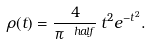<formula> <loc_0><loc_0><loc_500><loc_500>\rho ( t ) = \frac { 4 } { \pi ^ { \ h a l f } } \, t ^ { 2 } e ^ { - t ^ { 2 } } .</formula> 